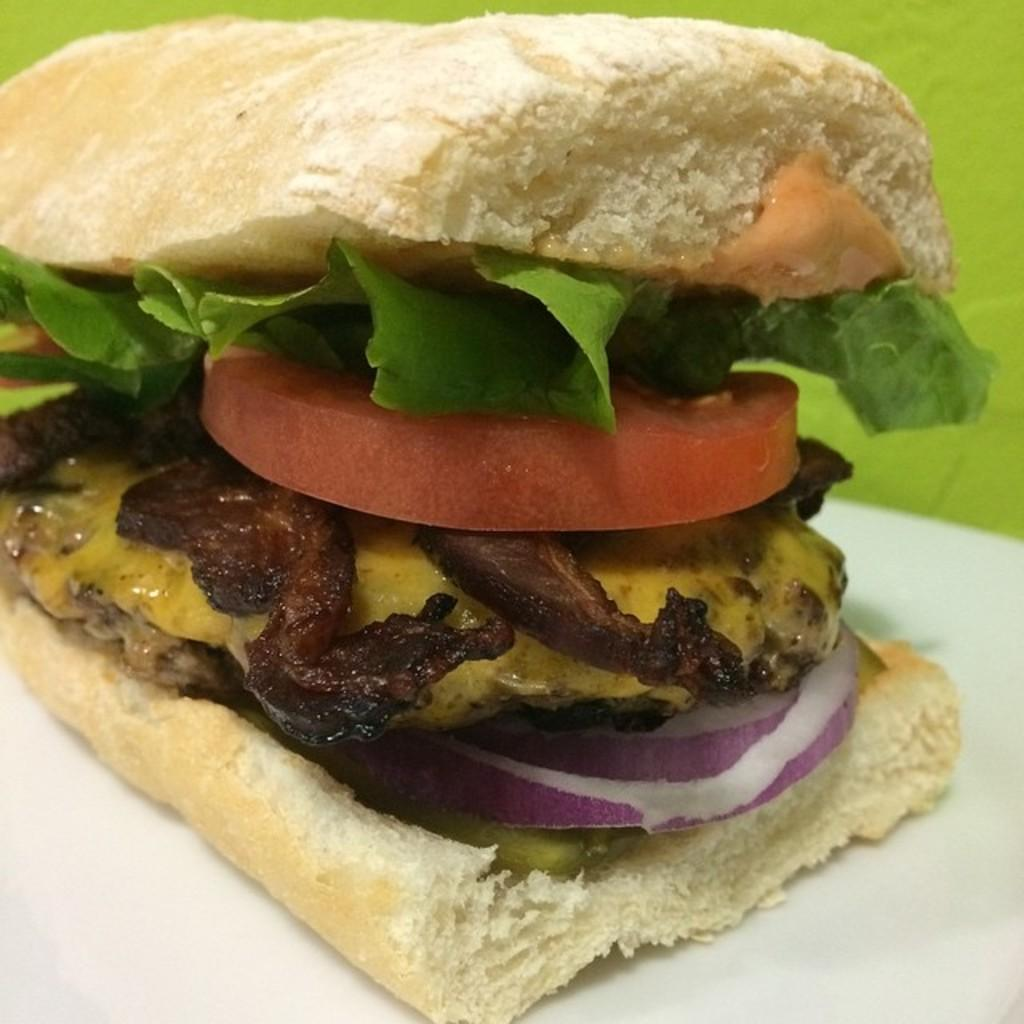What type of food is visible in the image? There is a sandwich in the image. Where is the sandwich located? The sandwich is placed on a surface. Is there a frog reading a book while smoking a pipe in the image? No, there is no frog, book, or pipe present in the image. 